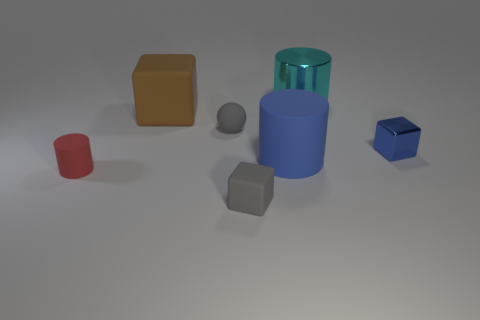Subtract all gray cylinders. Subtract all yellow cubes. How many cylinders are left? 3 Add 3 large shiny objects. How many objects exist? 10 Subtract all blocks. How many objects are left? 4 Add 1 metallic cylinders. How many metallic cylinders exist? 2 Subtract 0 brown balls. How many objects are left? 7 Subtract all blue matte cubes. Subtract all tiny gray balls. How many objects are left? 6 Add 6 gray rubber blocks. How many gray rubber blocks are left? 7 